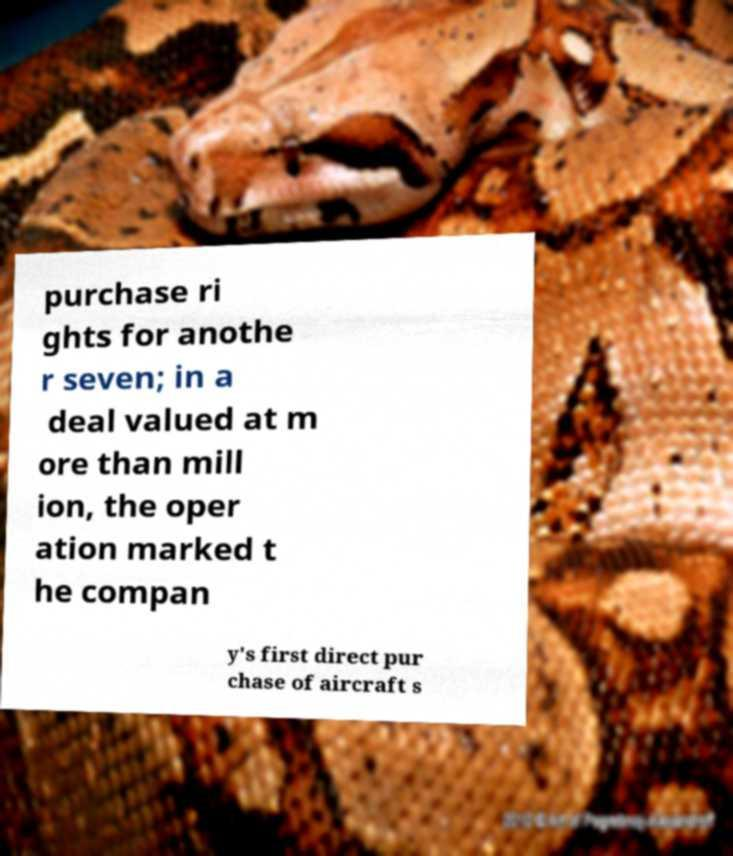Can you read and provide the text displayed in the image?This photo seems to have some interesting text. Can you extract and type it out for me? purchase ri ghts for anothe r seven; in a deal valued at m ore than mill ion, the oper ation marked t he compan y's first direct pur chase of aircraft s 